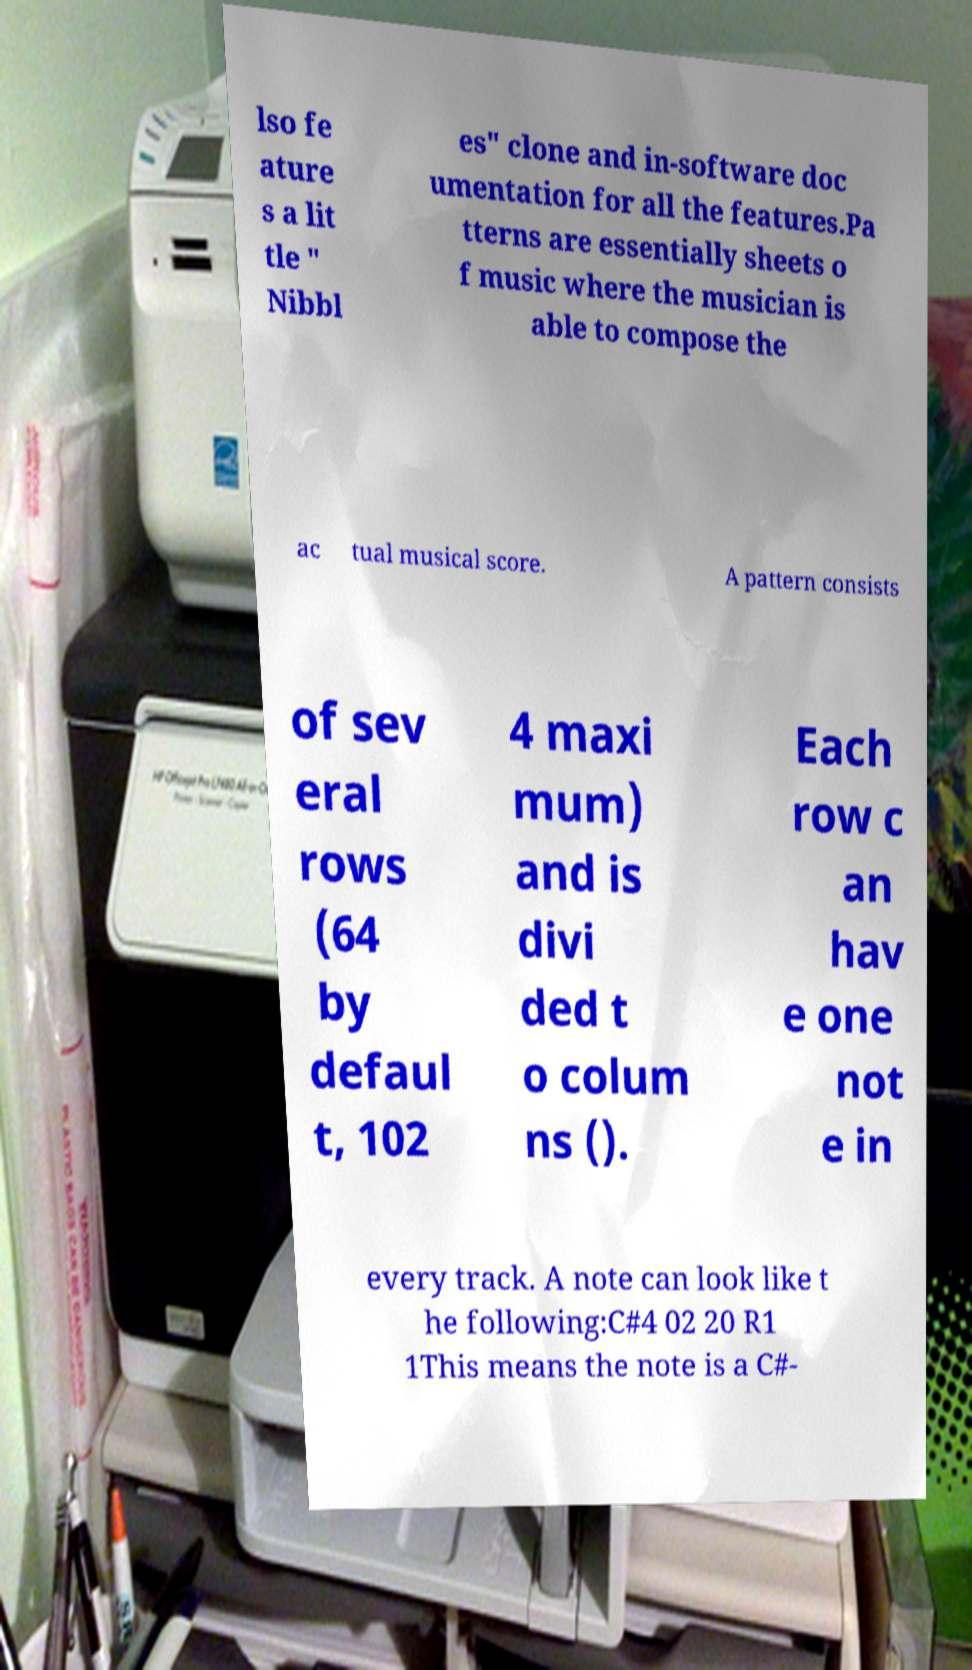There's text embedded in this image that I need extracted. Can you transcribe it verbatim? lso fe ature s a lit tle " Nibbl es" clone and in-software doc umentation for all the features.Pa tterns are essentially sheets o f music where the musician is able to compose the ac tual musical score. A pattern consists of sev eral rows (64 by defaul t, 102 4 maxi mum) and is divi ded t o colum ns (). Each row c an hav e one not e in every track. A note can look like t he following:C#4 02 20 R1 1This means the note is a C#- 